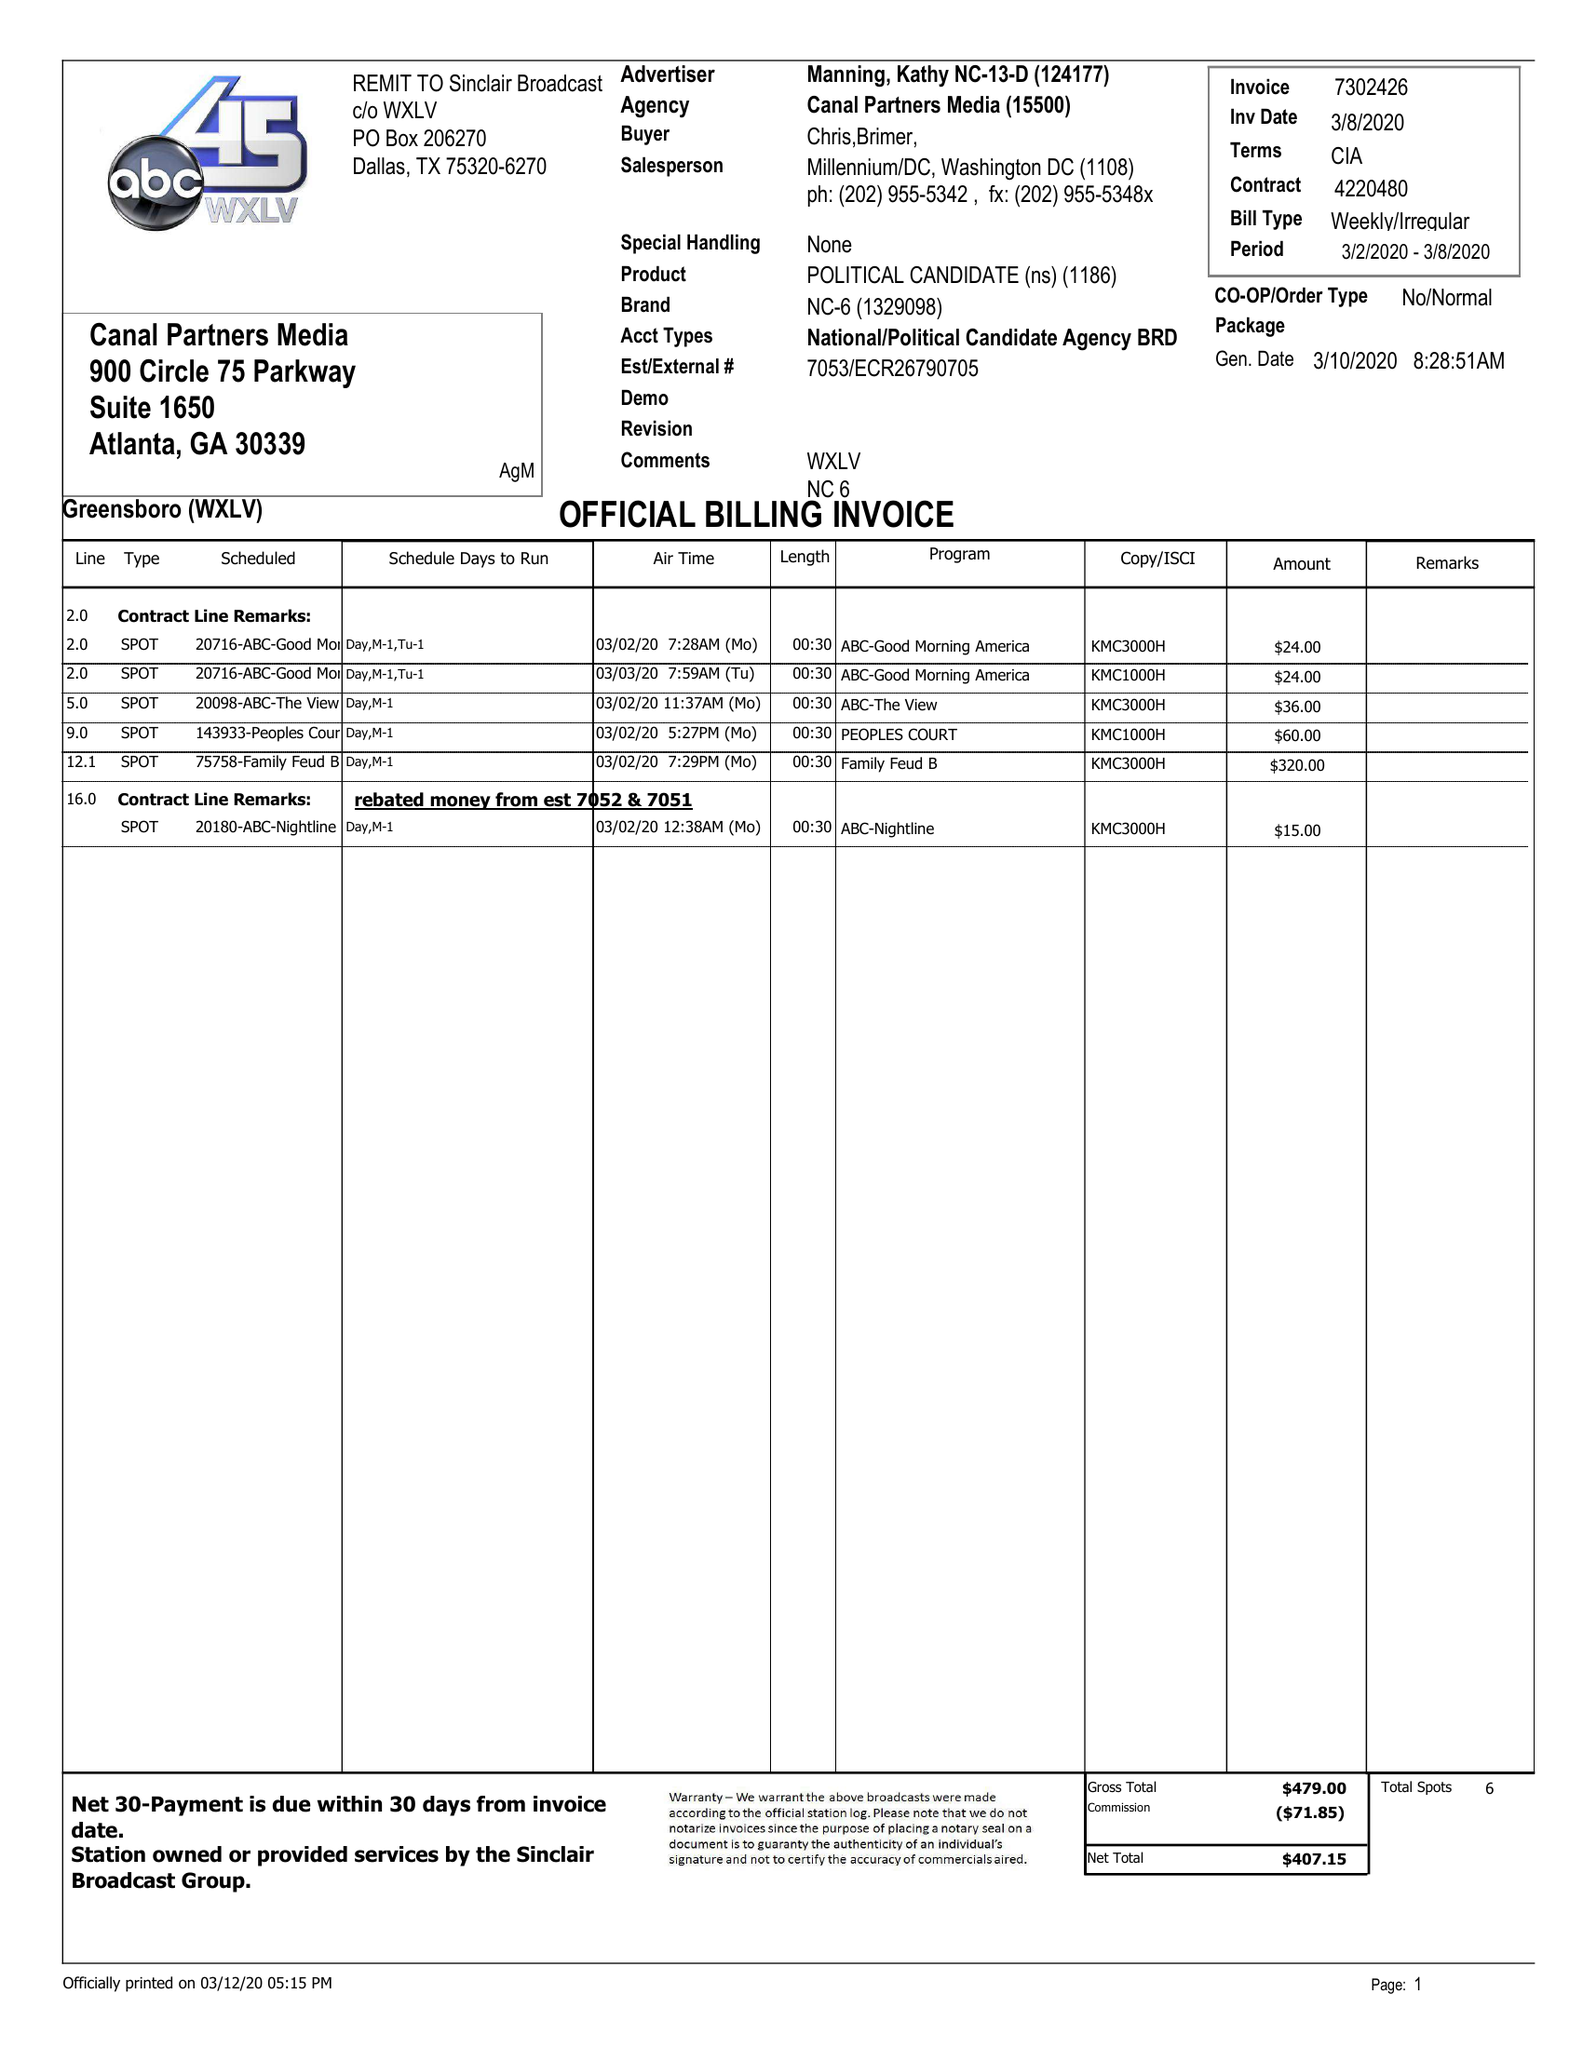What is the value for the contract_num?
Answer the question using a single word or phrase. 7302426 